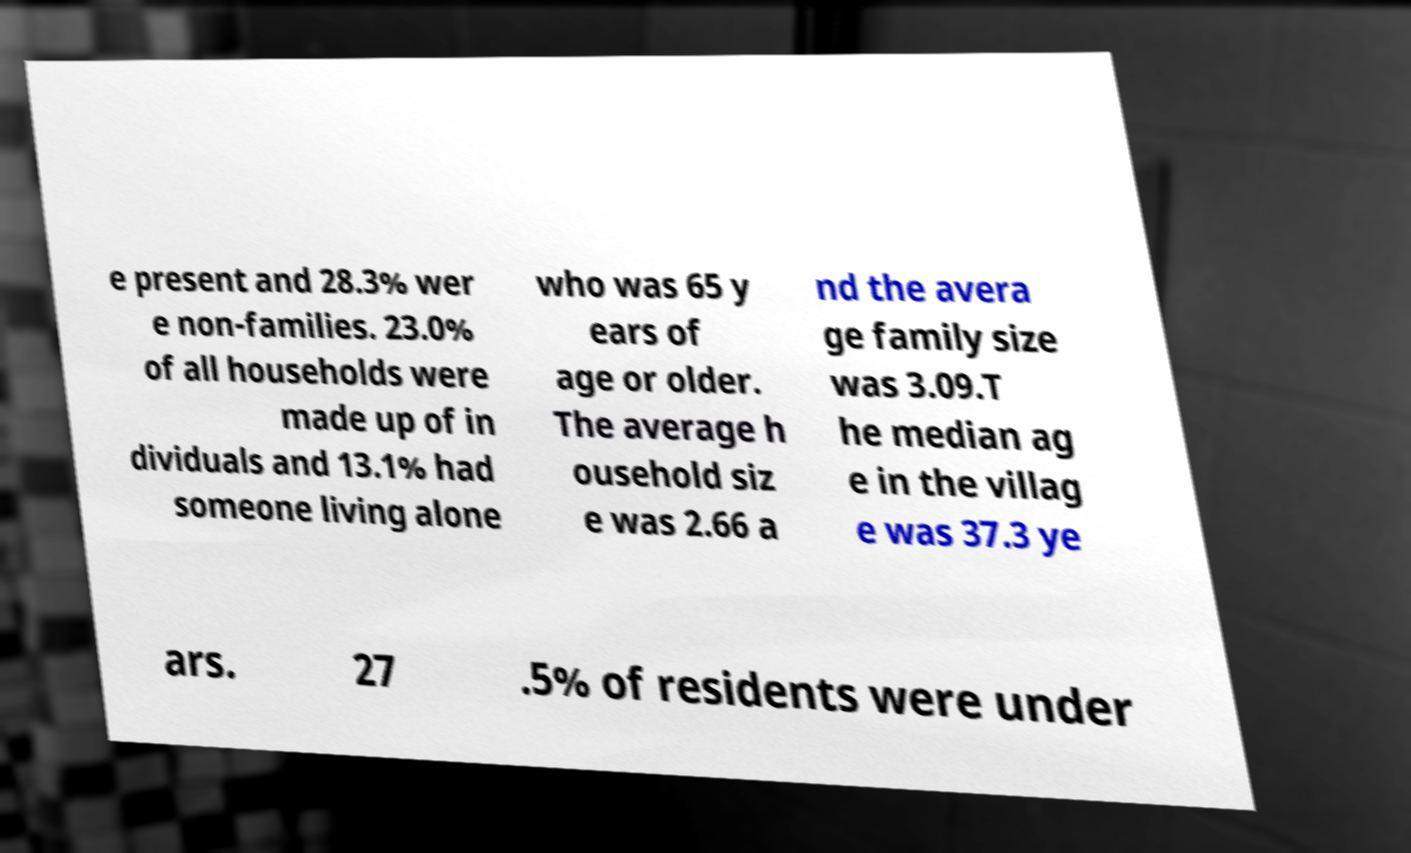Could you assist in decoding the text presented in this image and type it out clearly? e present and 28.3% wer e non-families. 23.0% of all households were made up of in dividuals and 13.1% had someone living alone who was 65 y ears of age or older. The average h ousehold siz e was 2.66 a nd the avera ge family size was 3.09.T he median ag e in the villag e was 37.3 ye ars. 27 .5% of residents were under 